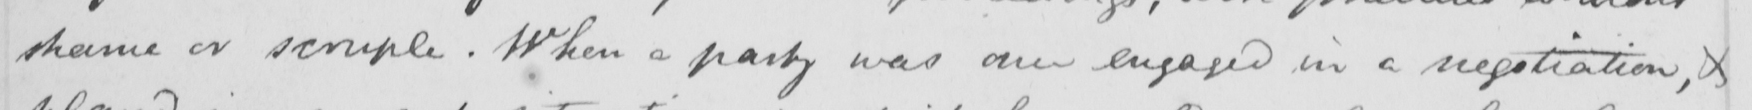What does this handwritten line say? shame or scruple . When a party was once engaged in a negotiation , & 